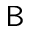<formula> <loc_0><loc_0><loc_500><loc_500>B</formula> 